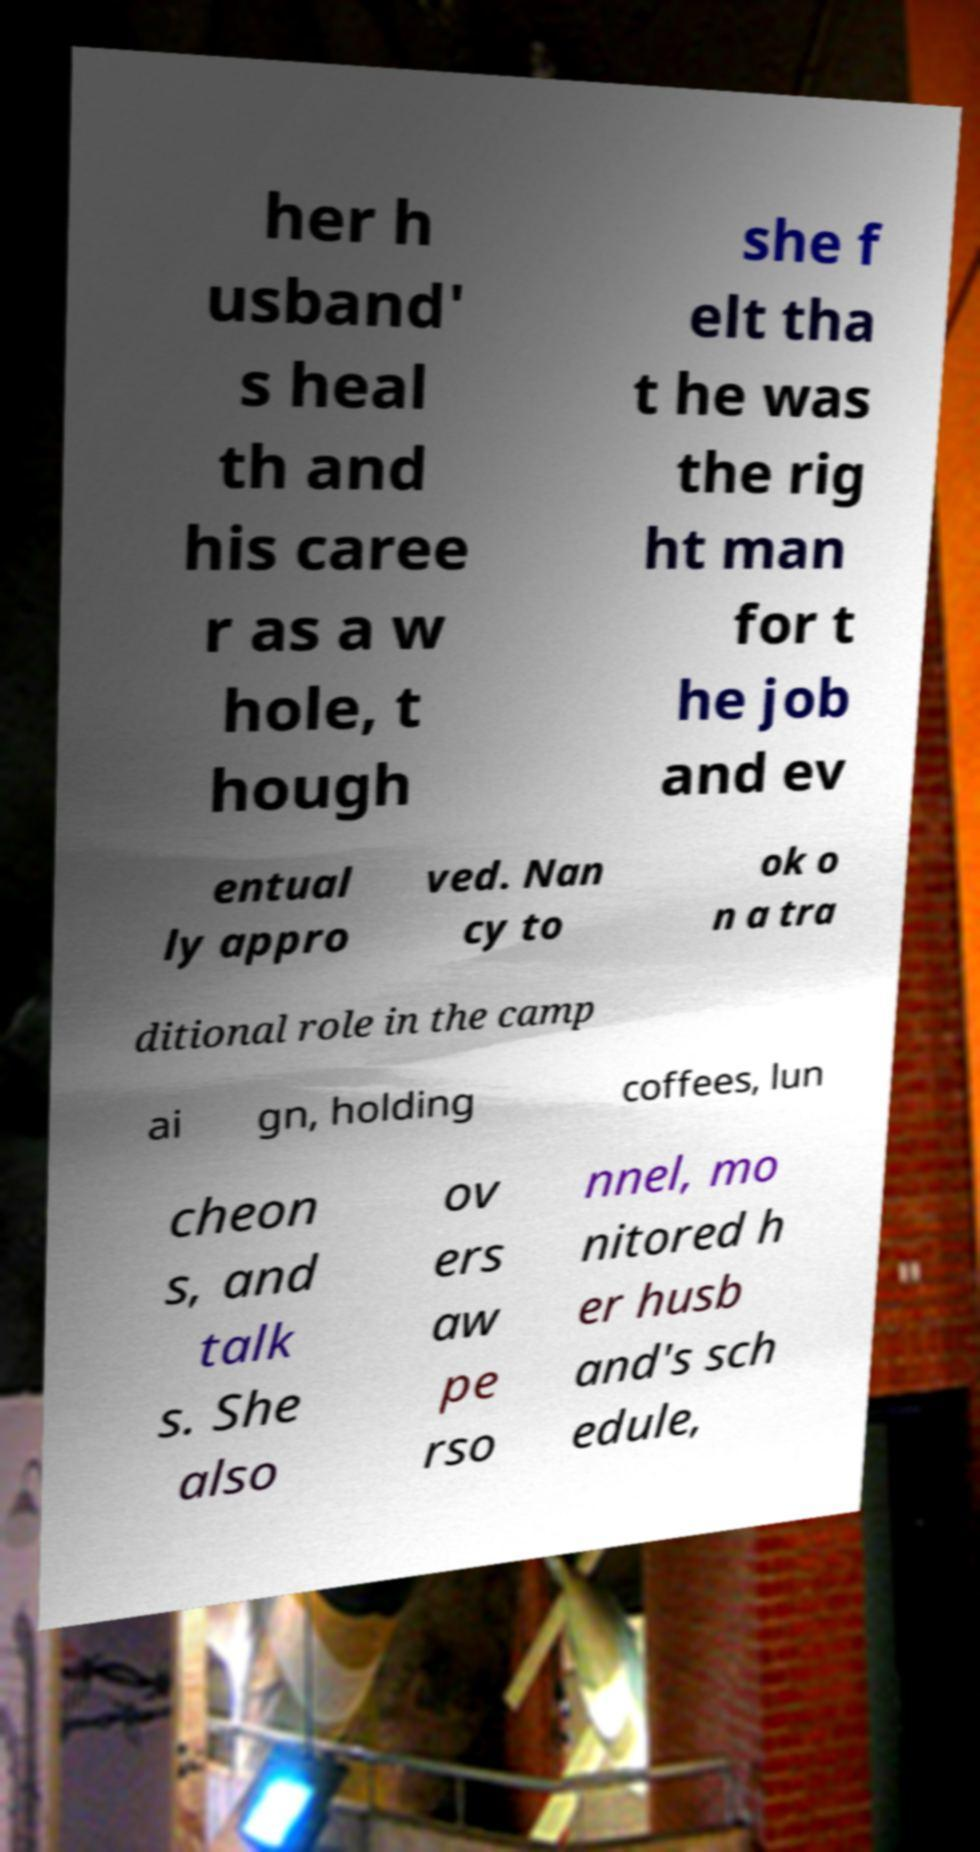I need the written content from this picture converted into text. Can you do that? her h usband' s heal th and his caree r as a w hole, t hough she f elt tha t he was the rig ht man for t he job and ev entual ly appro ved. Nan cy to ok o n a tra ditional role in the camp ai gn, holding coffees, lun cheon s, and talk s. She also ov ers aw pe rso nnel, mo nitored h er husb and's sch edule, 